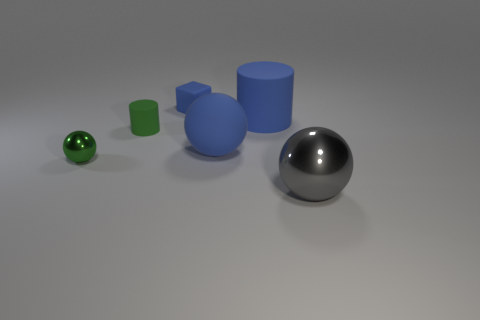Add 3 gray metallic things. How many objects exist? 9 Subtract all blue matte balls. How many balls are left? 2 Subtract 1 spheres. How many spheres are left? 2 Subtract all cylinders. How many objects are left? 4 Add 1 rubber blocks. How many rubber blocks are left? 2 Add 2 gray metal cylinders. How many gray metal cylinders exist? 2 Subtract 0 brown blocks. How many objects are left? 6 Subtract all cyan cylinders. Subtract all yellow blocks. How many cylinders are left? 2 Subtract all small green balls. Subtract all big blue rubber cylinders. How many objects are left? 4 